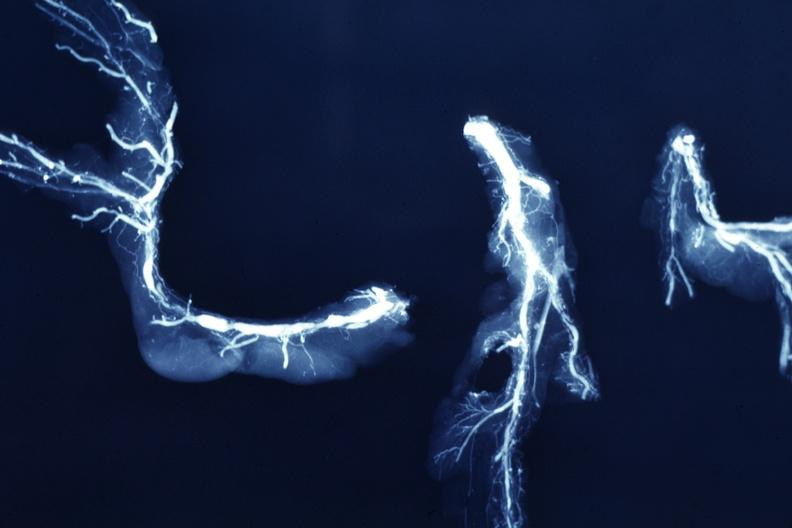what is present?
Answer the question using a single word or phrase. Vasculature 